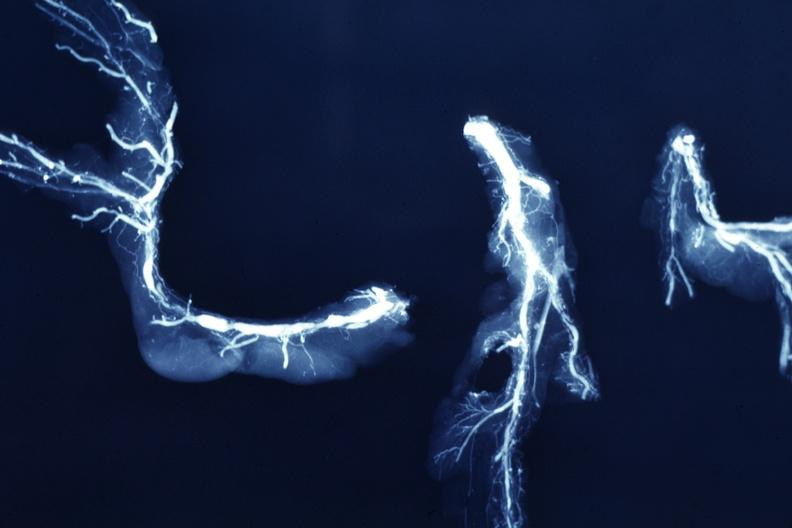what is present?
Answer the question using a single word or phrase. Vasculature 